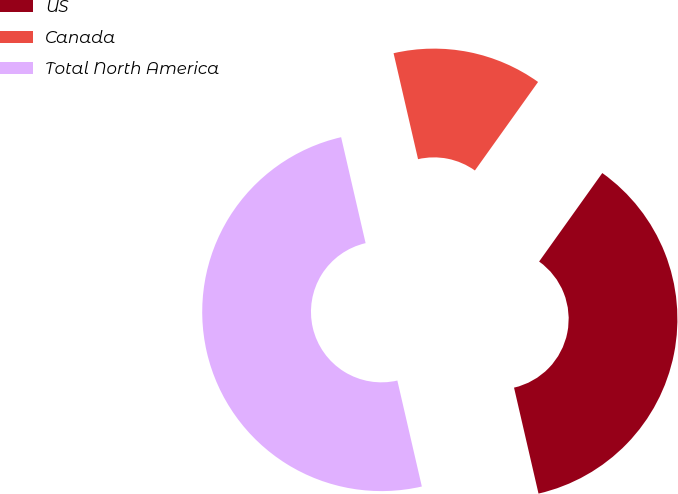Convert chart to OTSL. <chart><loc_0><loc_0><loc_500><loc_500><pie_chart><fcel>US<fcel>Canada<fcel>Total North America<nl><fcel>36.52%<fcel>13.48%<fcel>50.0%<nl></chart> 